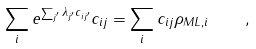Convert formula to latex. <formula><loc_0><loc_0><loc_500><loc_500>\sum _ { i } e ^ { \sum _ { j ^ { \prime } } \lambda _ { j ^ { \prime } } c _ { i j ^ { \prime } } } c _ { i j } = \sum _ { i } c _ { i j } \rho _ { M L , i } \quad ,</formula> 